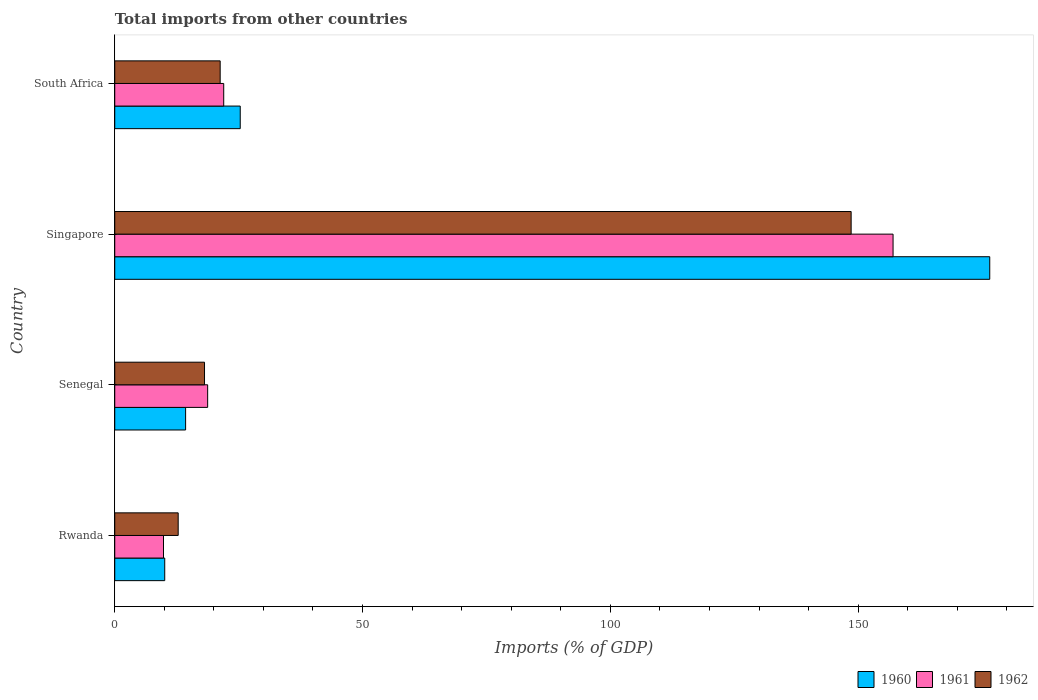How many groups of bars are there?
Your answer should be very brief. 4. How many bars are there on the 3rd tick from the bottom?
Your answer should be compact. 3. What is the label of the 2nd group of bars from the top?
Offer a very short reply. Singapore. What is the total imports in 1960 in Singapore?
Your response must be concise. 176.55. Across all countries, what is the maximum total imports in 1961?
Provide a succinct answer. 157.05. Across all countries, what is the minimum total imports in 1962?
Provide a short and direct response. 12.8. In which country was the total imports in 1961 maximum?
Make the answer very short. Singapore. In which country was the total imports in 1960 minimum?
Offer a very short reply. Rwanda. What is the total total imports in 1960 in the graph?
Offer a very short reply. 226.25. What is the difference between the total imports in 1962 in Rwanda and that in South Africa?
Offer a terse response. -8.47. What is the difference between the total imports in 1961 in Rwanda and the total imports in 1962 in South Africa?
Provide a short and direct response. -11.44. What is the average total imports in 1960 per country?
Make the answer very short. 56.56. What is the difference between the total imports in 1960 and total imports in 1961 in Senegal?
Your answer should be very brief. -4.45. In how many countries, is the total imports in 1961 greater than 160 %?
Your answer should be very brief. 0. What is the ratio of the total imports in 1960 in Rwanda to that in Singapore?
Offer a terse response. 0.06. Is the total imports in 1960 in Singapore less than that in South Africa?
Provide a short and direct response. No. What is the difference between the highest and the second highest total imports in 1960?
Ensure brevity in your answer.  151.24. What is the difference between the highest and the lowest total imports in 1961?
Offer a very short reply. 147.21. What does the 3rd bar from the top in Senegal represents?
Offer a terse response. 1960. Are all the bars in the graph horizontal?
Offer a very short reply. Yes. How many countries are there in the graph?
Give a very brief answer. 4. Are the values on the major ticks of X-axis written in scientific E-notation?
Ensure brevity in your answer.  No. How many legend labels are there?
Give a very brief answer. 3. What is the title of the graph?
Your response must be concise. Total imports from other countries. What is the label or title of the X-axis?
Make the answer very short. Imports (% of GDP). What is the label or title of the Y-axis?
Make the answer very short. Country. What is the Imports (% of GDP) of 1960 in Rwanda?
Give a very brief answer. 10.08. What is the Imports (% of GDP) of 1961 in Rwanda?
Offer a very short reply. 9.84. What is the Imports (% of GDP) in 1962 in Rwanda?
Make the answer very short. 12.8. What is the Imports (% of GDP) of 1960 in Senegal?
Your answer should be compact. 14.3. What is the Imports (% of GDP) of 1961 in Senegal?
Ensure brevity in your answer.  18.74. What is the Imports (% of GDP) of 1962 in Senegal?
Offer a very short reply. 18.11. What is the Imports (% of GDP) in 1960 in Singapore?
Offer a very short reply. 176.55. What is the Imports (% of GDP) in 1961 in Singapore?
Your answer should be compact. 157.05. What is the Imports (% of GDP) of 1962 in Singapore?
Provide a succinct answer. 148.59. What is the Imports (% of GDP) of 1960 in South Africa?
Keep it short and to the point. 25.32. What is the Imports (% of GDP) of 1961 in South Africa?
Make the answer very short. 21.99. What is the Imports (% of GDP) of 1962 in South Africa?
Your answer should be compact. 21.27. Across all countries, what is the maximum Imports (% of GDP) of 1960?
Your answer should be compact. 176.55. Across all countries, what is the maximum Imports (% of GDP) of 1961?
Ensure brevity in your answer.  157.05. Across all countries, what is the maximum Imports (% of GDP) of 1962?
Your response must be concise. 148.59. Across all countries, what is the minimum Imports (% of GDP) in 1960?
Make the answer very short. 10.08. Across all countries, what is the minimum Imports (% of GDP) of 1961?
Ensure brevity in your answer.  9.84. Across all countries, what is the minimum Imports (% of GDP) in 1962?
Offer a terse response. 12.8. What is the total Imports (% of GDP) in 1960 in the graph?
Provide a short and direct response. 226.25. What is the total Imports (% of GDP) of 1961 in the graph?
Offer a very short reply. 207.61. What is the total Imports (% of GDP) of 1962 in the graph?
Offer a terse response. 200.77. What is the difference between the Imports (% of GDP) of 1960 in Rwanda and that in Senegal?
Provide a succinct answer. -4.21. What is the difference between the Imports (% of GDP) of 1961 in Rwanda and that in Senegal?
Give a very brief answer. -8.91. What is the difference between the Imports (% of GDP) of 1962 in Rwanda and that in Senegal?
Provide a succinct answer. -5.31. What is the difference between the Imports (% of GDP) of 1960 in Rwanda and that in Singapore?
Provide a succinct answer. -166.47. What is the difference between the Imports (% of GDP) of 1961 in Rwanda and that in Singapore?
Your response must be concise. -147.21. What is the difference between the Imports (% of GDP) in 1962 in Rwanda and that in Singapore?
Offer a terse response. -135.79. What is the difference between the Imports (% of GDP) of 1960 in Rwanda and that in South Africa?
Make the answer very short. -15.24. What is the difference between the Imports (% of GDP) in 1961 in Rwanda and that in South Africa?
Your response must be concise. -12.15. What is the difference between the Imports (% of GDP) in 1962 in Rwanda and that in South Africa?
Your answer should be very brief. -8.47. What is the difference between the Imports (% of GDP) of 1960 in Senegal and that in Singapore?
Your response must be concise. -162.26. What is the difference between the Imports (% of GDP) of 1961 in Senegal and that in Singapore?
Provide a short and direct response. -138.3. What is the difference between the Imports (% of GDP) of 1962 in Senegal and that in Singapore?
Provide a short and direct response. -130.47. What is the difference between the Imports (% of GDP) in 1960 in Senegal and that in South Africa?
Offer a terse response. -11.02. What is the difference between the Imports (% of GDP) in 1961 in Senegal and that in South Africa?
Your answer should be compact. -3.24. What is the difference between the Imports (% of GDP) of 1962 in Senegal and that in South Africa?
Offer a very short reply. -3.16. What is the difference between the Imports (% of GDP) in 1960 in Singapore and that in South Africa?
Your response must be concise. 151.24. What is the difference between the Imports (% of GDP) in 1961 in Singapore and that in South Africa?
Offer a very short reply. 135.06. What is the difference between the Imports (% of GDP) in 1962 in Singapore and that in South Africa?
Offer a very short reply. 127.32. What is the difference between the Imports (% of GDP) in 1960 in Rwanda and the Imports (% of GDP) in 1961 in Senegal?
Your answer should be very brief. -8.66. What is the difference between the Imports (% of GDP) in 1960 in Rwanda and the Imports (% of GDP) in 1962 in Senegal?
Offer a very short reply. -8.03. What is the difference between the Imports (% of GDP) in 1961 in Rwanda and the Imports (% of GDP) in 1962 in Senegal?
Offer a very short reply. -8.28. What is the difference between the Imports (% of GDP) in 1960 in Rwanda and the Imports (% of GDP) in 1961 in Singapore?
Your answer should be compact. -146.96. What is the difference between the Imports (% of GDP) of 1960 in Rwanda and the Imports (% of GDP) of 1962 in Singapore?
Keep it short and to the point. -138.5. What is the difference between the Imports (% of GDP) in 1961 in Rwanda and the Imports (% of GDP) in 1962 in Singapore?
Keep it short and to the point. -138.75. What is the difference between the Imports (% of GDP) of 1960 in Rwanda and the Imports (% of GDP) of 1961 in South Africa?
Offer a very short reply. -11.9. What is the difference between the Imports (% of GDP) in 1960 in Rwanda and the Imports (% of GDP) in 1962 in South Africa?
Provide a short and direct response. -11.19. What is the difference between the Imports (% of GDP) of 1961 in Rwanda and the Imports (% of GDP) of 1962 in South Africa?
Make the answer very short. -11.44. What is the difference between the Imports (% of GDP) in 1960 in Senegal and the Imports (% of GDP) in 1961 in Singapore?
Make the answer very short. -142.75. What is the difference between the Imports (% of GDP) in 1960 in Senegal and the Imports (% of GDP) in 1962 in Singapore?
Offer a very short reply. -134.29. What is the difference between the Imports (% of GDP) in 1961 in Senegal and the Imports (% of GDP) in 1962 in Singapore?
Provide a short and direct response. -129.84. What is the difference between the Imports (% of GDP) of 1960 in Senegal and the Imports (% of GDP) of 1961 in South Africa?
Offer a very short reply. -7.69. What is the difference between the Imports (% of GDP) in 1960 in Senegal and the Imports (% of GDP) in 1962 in South Africa?
Offer a terse response. -6.98. What is the difference between the Imports (% of GDP) in 1961 in Senegal and the Imports (% of GDP) in 1962 in South Africa?
Your response must be concise. -2.53. What is the difference between the Imports (% of GDP) of 1960 in Singapore and the Imports (% of GDP) of 1961 in South Africa?
Your answer should be compact. 154.57. What is the difference between the Imports (% of GDP) of 1960 in Singapore and the Imports (% of GDP) of 1962 in South Africa?
Your response must be concise. 155.28. What is the difference between the Imports (% of GDP) of 1961 in Singapore and the Imports (% of GDP) of 1962 in South Africa?
Ensure brevity in your answer.  135.77. What is the average Imports (% of GDP) of 1960 per country?
Give a very brief answer. 56.56. What is the average Imports (% of GDP) of 1961 per country?
Make the answer very short. 51.9. What is the average Imports (% of GDP) of 1962 per country?
Provide a succinct answer. 50.19. What is the difference between the Imports (% of GDP) in 1960 and Imports (% of GDP) in 1961 in Rwanda?
Give a very brief answer. 0.25. What is the difference between the Imports (% of GDP) in 1960 and Imports (% of GDP) in 1962 in Rwanda?
Make the answer very short. -2.72. What is the difference between the Imports (% of GDP) in 1961 and Imports (% of GDP) in 1962 in Rwanda?
Provide a succinct answer. -2.96. What is the difference between the Imports (% of GDP) in 1960 and Imports (% of GDP) in 1961 in Senegal?
Your answer should be compact. -4.45. What is the difference between the Imports (% of GDP) in 1960 and Imports (% of GDP) in 1962 in Senegal?
Ensure brevity in your answer.  -3.82. What is the difference between the Imports (% of GDP) of 1961 and Imports (% of GDP) of 1962 in Senegal?
Offer a terse response. 0.63. What is the difference between the Imports (% of GDP) of 1960 and Imports (% of GDP) of 1961 in Singapore?
Provide a short and direct response. 19.51. What is the difference between the Imports (% of GDP) in 1960 and Imports (% of GDP) in 1962 in Singapore?
Your answer should be very brief. 27.97. What is the difference between the Imports (% of GDP) of 1961 and Imports (% of GDP) of 1962 in Singapore?
Provide a short and direct response. 8.46. What is the difference between the Imports (% of GDP) in 1960 and Imports (% of GDP) in 1962 in South Africa?
Your answer should be very brief. 4.05. What is the difference between the Imports (% of GDP) in 1961 and Imports (% of GDP) in 1962 in South Africa?
Your answer should be very brief. 0.71. What is the ratio of the Imports (% of GDP) of 1960 in Rwanda to that in Senegal?
Keep it short and to the point. 0.71. What is the ratio of the Imports (% of GDP) of 1961 in Rwanda to that in Senegal?
Your answer should be very brief. 0.52. What is the ratio of the Imports (% of GDP) of 1962 in Rwanda to that in Senegal?
Keep it short and to the point. 0.71. What is the ratio of the Imports (% of GDP) in 1960 in Rwanda to that in Singapore?
Ensure brevity in your answer.  0.06. What is the ratio of the Imports (% of GDP) in 1961 in Rwanda to that in Singapore?
Ensure brevity in your answer.  0.06. What is the ratio of the Imports (% of GDP) of 1962 in Rwanda to that in Singapore?
Give a very brief answer. 0.09. What is the ratio of the Imports (% of GDP) in 1960 in Rwanda to that in South Africa?
Keep it short and to the point. 0.4. What is the ratio of the Imports (% of GDP) of 1961 in Rwanda to that in South Africa?
Offer a very short reply. 0.45. What is the ratio of the Imports (% of GDP) of 1962 in Rwanda to that in South Africa?
Provide a short and direct response. 0.6. What is the ratio of the Imports (% of GDP) of 1960 in Senegal to that in Singapore?
Keep it short and to the point. 0.08. What is the ratio of the Imports (% of GDP) in 1961 in Senegal to that in Singapore?
Give a very brief answer. 0.12. What is the ratio of the Imports (% of GDP) in 1962 in Senegal to that in Singapore?
Offer a terse response. 0.12. What is the ratio of the Imports (% of GDP) of 1960 in Senegal to that in South Africa?
Your answer should be very brief. 0.56. What is the ratio of the Imports (% of GDP) in 1961 in Senegal to that in South Africa?
Ensure brevity in your answer.  0.85. What is the ratio of the Imports (% of GDP) of 1962 in Senegal to that in South Africa?
Make the answer very short. 0.85. What is the ratio of the Imports (% of GDP) in 1960 in Singapore to that in South Africa?
Offer a very short reply. 6.97. What is the ratio of the Imports (% of GDP) of 1961 in Singapore to that in South Africa?
Provide a succinct answer. 7.14. What is the ratio of the Imports (% of GDP) in 1962 in Singapore to that in South Africa?
Provide a succinct answer. 6.99. What is the difference between the highest and the second highest Imports (% of GDP) of 1960?
Make the answer very short. 151.24. What is the difference between the highest and the second highest Imports (% of GDP) in 1961?
Offer a very short reply. 135.06. What is the difference between the highest and the second highest Imports (% of GDP) in 1962?
Your answer should be compact. 127.32. What is the difference between the highest and the lowest Imports (% of GDP) of 1960?
Keep it short and to the point. 166.47. What is the difference between the highest and the lowest Imports (% of GDP) of 1961?
Offer a terse response. 147.21. What is the difference between the highest and the lowest Imports (% of GDP) in 1962?
Your answer should be very brief. 135.79. 